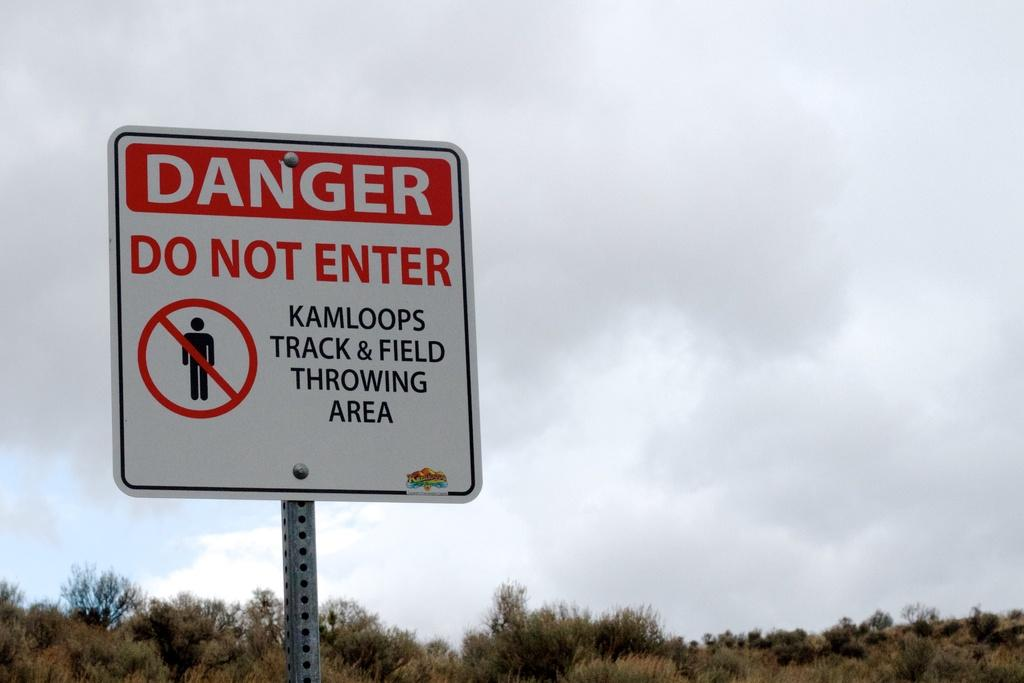Provide a one-sentence caption for the provided image. A warning sign to not enter the track & field area. 